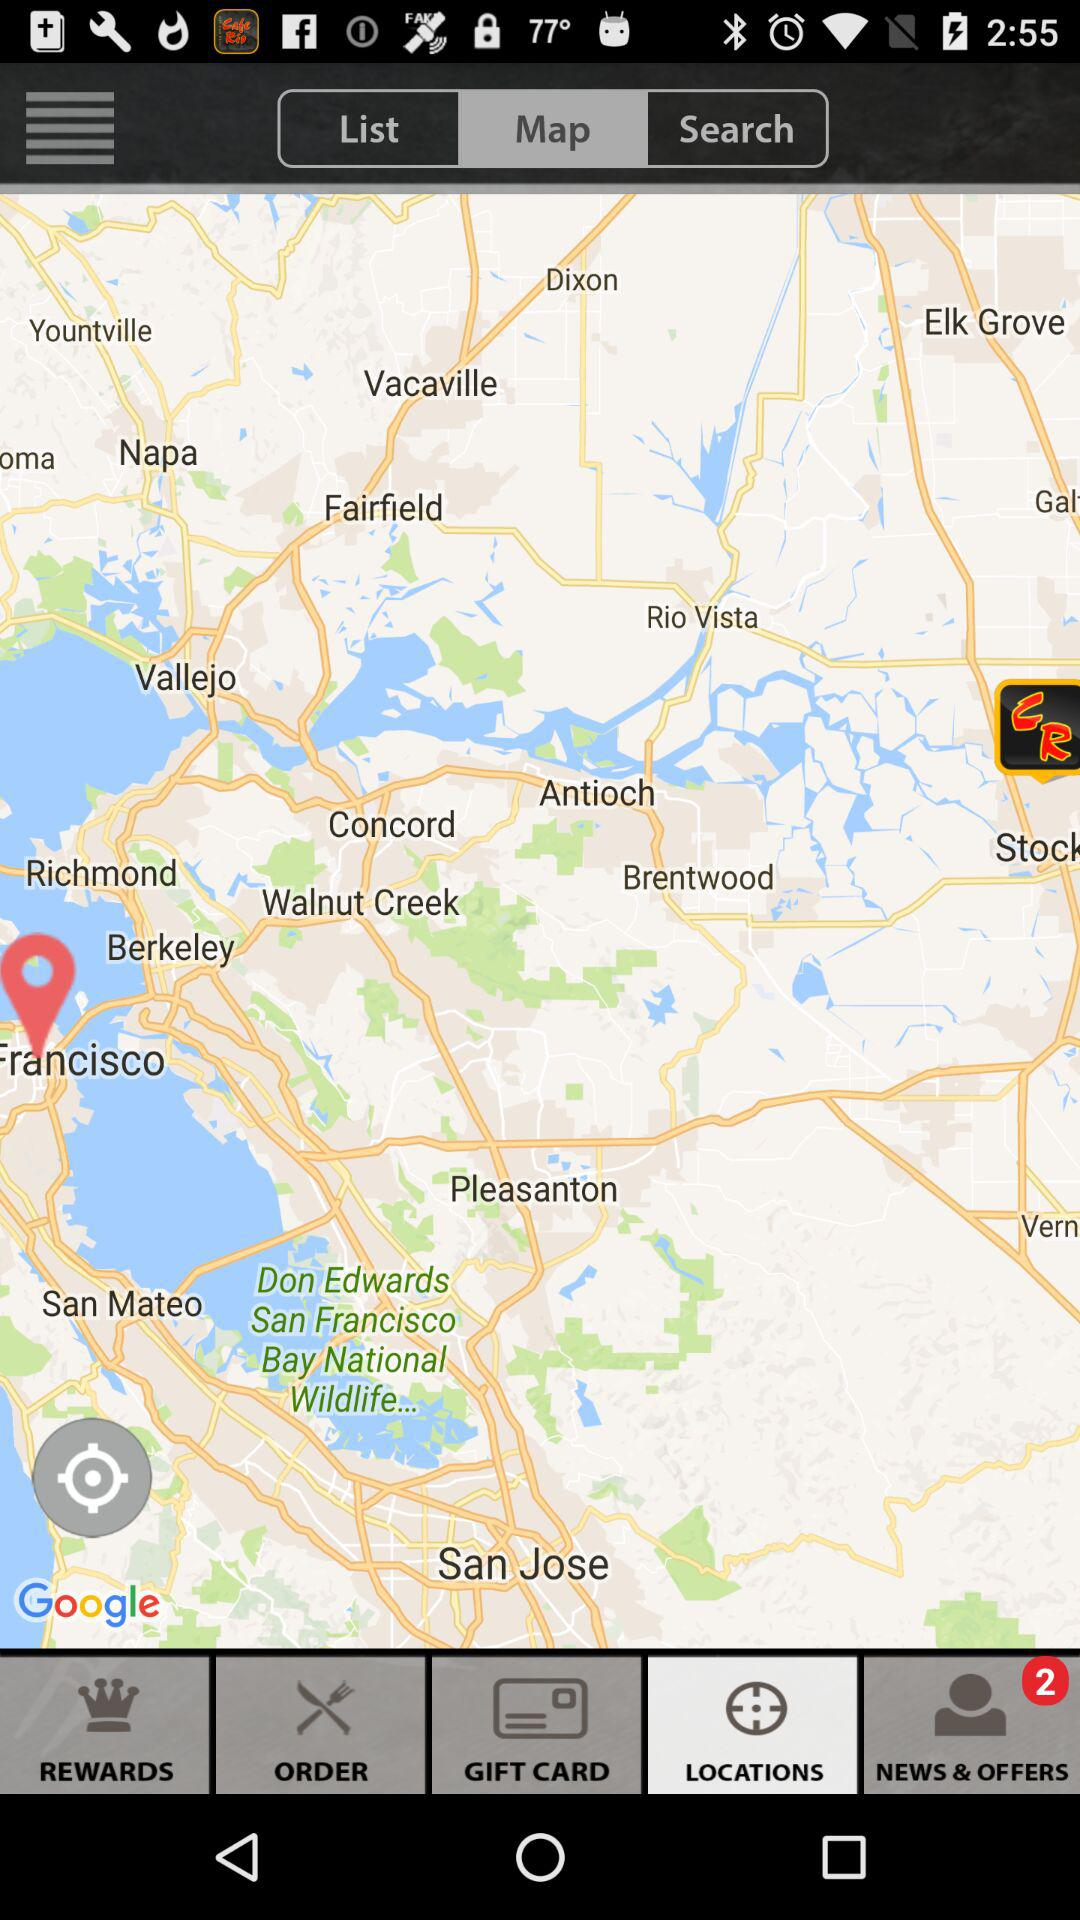What is the number of notifications in "NEWS & OFFERS"? The number of notifications for "NEWS & OFFERS" is 2. 